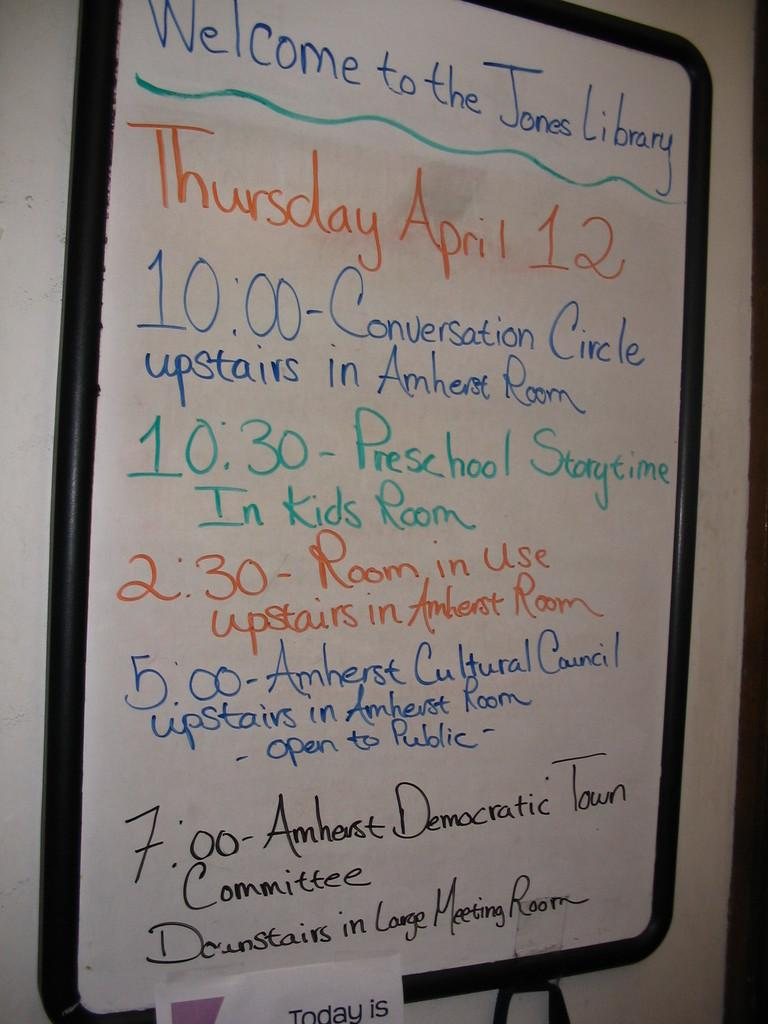<image>
Present a compact description of the photo's key features. A whiteboard welcoming people to the Jones Library also showing the the times of different events and times. 